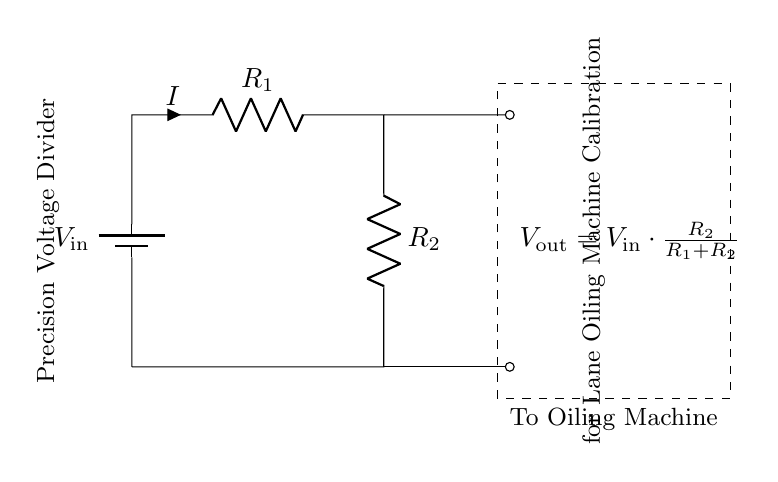What is the input voltage of the circuit? The input voltage, labeled as "V_in," is specified in the circuit diagram as the voltage supplied to the voltage divider.
Answer: V_in What are the resistances in the voltage divider? The circuit shows two resistors, R_1 and R_2, which are part of the voltage divider. These resistors determine the output voltage based on their values.
Answer: R_1, R_2 What is the expression for the output voltage? The output voltage, labeled as "V_out," is mathematically expressed in the diagram as the formula "V_out = V_in * (R_2 / (R_1 + R_2))". This expression indicates how the input voltage is divided between the resistors.
Answer: V_out = V_in * (R_2 / (R_1 + R_2)) How is the output voltage related to the resistors? The output voltage is derived from the ratio of the resistances R_2 and the sum of R_1 and R_2, indicating a proportional relationship. As R_2 increases relative to R_1, V_out increases.
Answer: Proportional relationship What is the purpose of this voltage divider circuit? This precision voltage divider is specifically designed for the calibration of the lane oiling machines, as stated in the diagram. It provides the required voltage level for accurate calibration.
Answer: Calibration of lane oiling machines What happens if R_2 is much larger than R_1? If R_2 is significantly larger than R_1, the output voltage (V_out) will approach the input voltage (V_in), indicating less division and higher output. This significantly alters the performance of the circuit.
Answer: Approaches V_in 